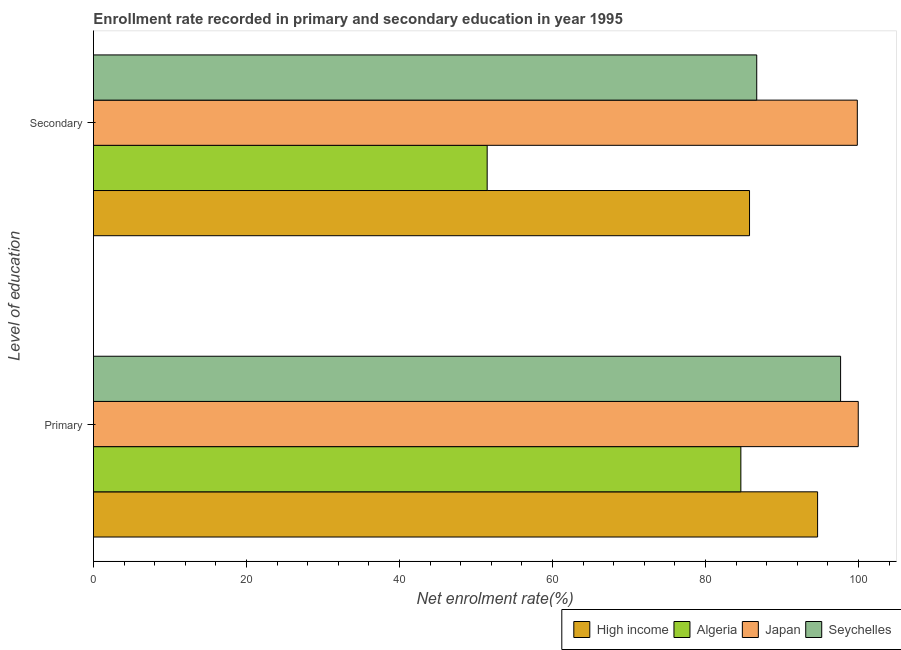Are the number of bars on each tick of the Y-axis equal?
Offer a very short reply. Yes. How many bars are there on the 1st tick from the top?
Provide a succinct answer. 4. What is the label of the 2nd group of bars from the top?
Your answer should be compact. Primary. What is the enrollment rate in secondary education in Seychelles?
Make the answer very short. 86.69. Across all countries, what is the maximum enrollment rate in primary education?
Make the answer very short. 99.96. Across all countries, what is the minimum enrollment rate in secondary education?
Provide a short and direct response. 51.46. In which country was the enrollment rate in primary education minimum?
Make the answer very short. Algeria. What is the total enrollment rate in primary education in the graph?
Your answer should be compact. 376.87. What is the difference between the enrollment rate in secondary education in Seychelles and that in High income?
Your response must be concise. 0.94. What is the difference between the enrollment rate in secondary education in Algeria and the enrollment rate in primary education in Japan?
Your answer should be very brief. -48.5. What is the average enrollment rate in secondary education per country?
Offer a terse response. 80.93. What is the difference between the enrollment rate in primary education and enrollment rate in secondary education in Algeria?
Ensure brevity in your answer.  33.16. What is the ratio of the enrollment rate in secondary education in Seychelles to that in High income?
Provide a succinct answer. 1.01. Is the enrollment rate in secondary education in Algeria less than that in High income?
Offer a very short reply. Yes. In how many countries, is the enrollment rate in primary education greater than the average enrollment rate in primary education taken over all countries?
Provide a short and direct response. 3. What does the 2nd bar from the top in Primary represents?
Offer a very short reply. Japan. What does the 2nd bar from the bottom in Primary represents?
Offer a terse response. Algeria. How many bars are there?
Offer a terse response. 8. What is the difference between two consecutive major ticks on the X-axis?
Provide a short and direct response. 20. Are the values on the major ticks of X-axis written in scientific E-notation?
Your answer should be very brief. No. Does the graph contain grids?
Provide a short and direct response. No. Where does the legend appear in the graph?
Ensure brevity in your answer.  Bottom right. How are the legend labels stacked?
Provide a succinct answer. Horizontal. What is the title of the graph?
Offer a terse response. Enrollment rate recorded in primary and secondary education in year 1995. What is the label or title of the X-axis?
Offer a very short reply. Net enrolment rate(%). What is the label or title of the Y-axis?
Ensure brevity in your answer.  Level of education. What is the Net enrolment rate(%) in High income in Primary?
Your response must be concise. 94.64. What is the Net enrolment rate(%) in Algeria in Primary?
Your answer should be compact. 84.62. What is the Net enrolment rate(%) of Japan in Primary?
Your response must be concise. 99.96. What is the Net enrolment rate(%) in Seychelles in Primary?
Make the answer very short. 97.65. What is the Net enrolment rate(%) of High income in Secondary?
Make the answer very short. 85.75. What is the Net enrolment rate(%) of Algeria in Secondary?
Keep it short and to the point. 51.46. What is the Net enrolment rate(%) of Japan in Secondary?
Provide a succinct answer. 99.84. What is the Net enrolment rate(%) in Seychelles in Secondary?
Make the answer very short. 86.69. Across all Level of education, what is the maximum Net enrolment rate(%) in High income?
Your response must be concise. 94.64. Across all Level of education, what is the maximum Net enrolment rate(%) in Algeria?
Ensure brevity in your answer.  84.62. Across all Level of education, what is the maximum Net enrolment rate(%) of Japan?
Give a very brief answer. 99.96. Across all Level of education, what is the maximum Net enrolment rate(%) in Seychelles?
Provide a short and direct response. 97.65. Across all Level of education, what is the minimum Net enrolment rate(%) in High income?
Ensure brevity in your answer.  85.75. Across all Level of education, what is the minimum Net enrolment rate(%) of Algeria?
Your response must be concise. 51.46. Across all Level of education, what is the minimum Net enrolment rate(%) of Japan?
Your response must be concise. 99.84. Across all Level of education, what is the minimum Net enrolment rate(%) in Seychelles?
Provide a short and direct response. 86.69. What is the total Net enrolment rate(%) of High income in the graph?
Offer a terse response. 180.39. What is the total Net enrolment rate(%) of Algeria in the graph?
Make the answer very short. 136.07. What is the total Net enrolment rate(%) in Japan in the graph?
Give a very brief answer. 199.79. What is the total Net enrolment rate(%) in Seychelles in the graph?
Ensure brevity in your answer.  184.34. What is the difference between the Net enrolment rate(%) of High income in Primary and that in Secondary?
Offer a very short reply. 8.9. What is the difference between the Net enrolment rate(%) of Algeria in Primary and that in Secondary?
Offer a terse response. 33.16. What is the difference between the Net enrolment rate(%) in Japan in Primary and that in Secondary?
Offer a terse response. 0.12. What is the difference between the Net enrolment rate(%) in Seychelles in Primary and that in Secondary?
Provide a succinct answer. 10.96. What is the difference between the Net enrolment rate(%) in High income in Primary and the Net enrolment rate(%) in Algeria in Secondary?
Ensure brevity in your answer.  43.19. What is the difference between the Net enrolment rate(%) of High income in Primary and the Net enrolment rate(%) of Japan in Secondary?
Make the answer very short. -5.19. What is the difference between the Net enrolment rate(%) of High income in Primary and the Net enrolment rate(%) of Seychelles in Secondary?
Your response must be concise. 7.95. What is the difference between the Net enrolment rate(%) in Algeria in Primary and the Net enrolment rate(%) in Japan in Secondary?
Make the answer very short. -15.22. What is the difference between the Net enrolment rate(%) of Algeria in Primary and the Net enrolment rate(%) of Seychelles in Secondary?
Keep it short and to the point. -2.08. What is the difference between the Net enrolment rate(%) in Japan in Primary and the Net enrolment rate(%) in Seychelles in Secondary?
Ensure brevity in your answer.  13.27. What is the average Net enrolment rate(%) of High income per Level of education?
Your answer should be very brief. 90.2. What is the average Net enrolment rate(%) of Algeria per Level of education?
Keep it short and to the point. 68.04. What is the average Net enrolment rate(%) in Japan per Level of education?
Provide a succinct answer. 99.9. What is the average Net enrolment rate(%) of Seychelles per Level of education?
Ensure brevity in your answer.  92.17. What is the difference between the Net enrolment rate(%) in High income and Net enrolment rate(%) in Algeria in Primary?
Make the answer very short. 10.03. What is the difference between the Net enrolment rate(%) in High income and Net enrolment rate(%) in Japan in Primary?
Your answer should be compact. -5.31. What is the difference between the Net enrolment rate(%) of High income and Net enrolment rate(%) of Seychelles in Primary?
Keep it short and to the point. -3.01. What is the difference between the Net enrolment rate(%) in Algeria and Net enrolment rate(%) in Japan in Primary?
Give a very brief answer. -15.34. What is the difference between the Net enrolment rate(%) in Algeria and Net enrolment rate(%) in Seychelles in Primary?
Your answer should be very brief. -13.04. What is the difference between the Net enrolment rate(%) of Japan and Net enrolment rate(%) of Seychelles in Primary?
Your answer should be compact. 2.31. What is the difference between the Net enrolment rate(%) of High income and Net enrolment rate(%) of Algeria in Secondary?
Ensure brevity in your answer.  34.29. What is the difference between the Net enrolment rate(%) in High income and Net enrolment rate(%) in Japan in Secondary?
Keep it short and to the point. -14.09. What is the difference between the Net enrolment rate(%) of High income and Net enrolment rate(%) of Seychelles in Secondary?
Provide a succinct answer. -0.94. What is the difference between the Net enrolment rate(%) in Algeria and Net enrolment rate(%) in Japan in Secondary?
Provide a succinct answer. -48.38. What is the difference between the Net enrolment rate(%) in Algeria and Net enrolment rate(%) in Seychelles in Secondary?
Your answer should be compact. -35.23. What is the difference between the Net enrolment rate(%) in Japan and Net enrolment rate(%) in Seychelles in Secondary?
Give a very brief answer. 13.15. What is the ratio of the Net enrolment rate(%) in High income in Primary to that in Secondary?
Give a very brief answer. 1.1. What is the ratio of the Net enrolment rate(%) of Algeria in Primary to that in Secondary?
Provide a short and direct response. 1.64. What is the ratio of the Net enrolment rate(%) in Japan in Primary to that in Secondary?
Provide a short and direct response. 1. What is the ratio of the Net enrolment rate(%) of Seychelles in Primary to that in Secondary?
Keep it short and to the point. 1.13. What is the difference between the highest and the second highest Net enrolment rate(%) in High income?
Your answer should be compact. 8.9. What is the difference between the highest and the second highest Net enrolment rate(%) in Algeria?
Your answer should be compact. 33.16. What is the difference between the highest and the second highest Net enrolment rate(%) of Japan?
Provide a succinct answer. 0.12. What is the difference between the highest and the second highest Net enrolment rate(%) in Seychelles?
Provide a succinct answer. 10.96. What is the difference between the highest and the lowest Net enrolment rate(%) in High income?
Make the answer very short. 8.9. What is the difference between the highest and the lowest Net enrolment rate(%) of Algeria?
Your answer should be very brief. 33.16. What is the difference between the highest and the lowest Net enrolment rate(%) of Japan?
Ensure brevity in your answer.  0.12. What is the difference between the highest and the lowest Net enrolment rate(%) in Seychelles?
Provide a short and direct response. 10.96. 